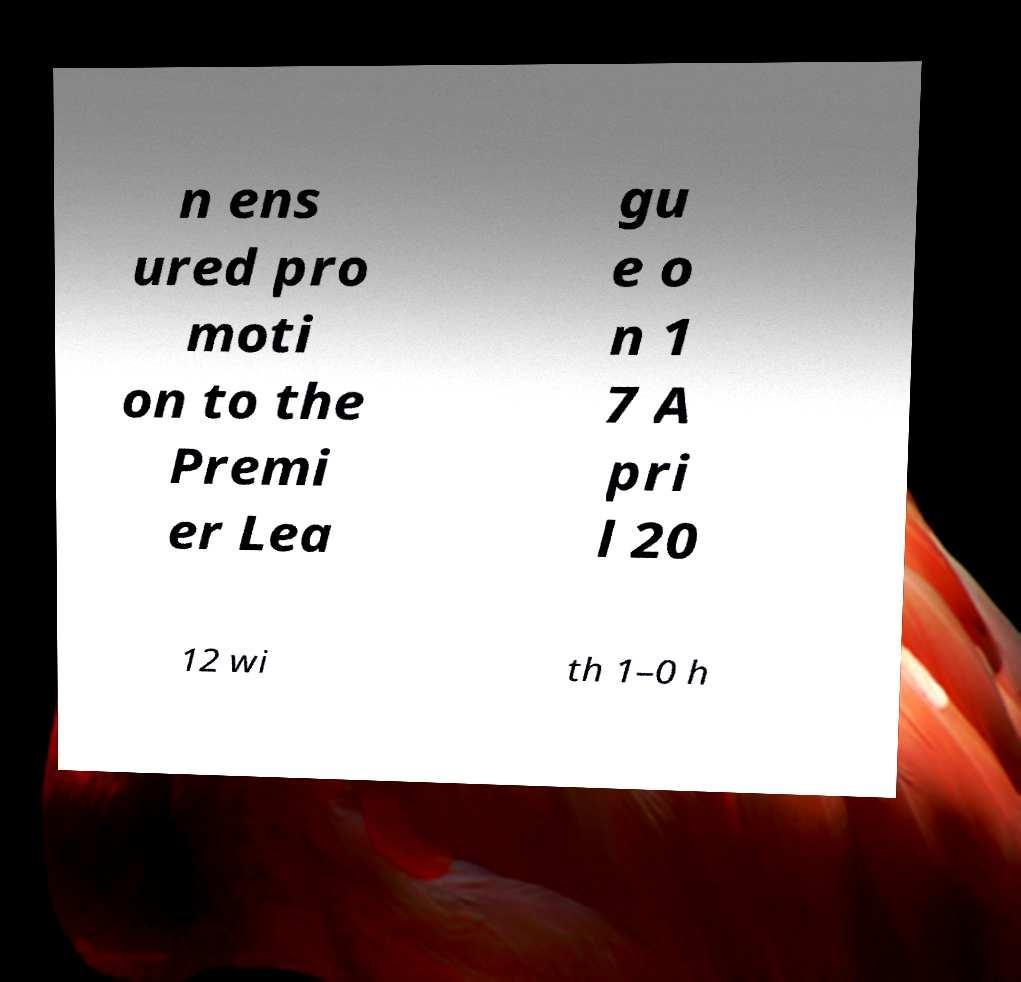I need the written content from this picture converted into text. Can you do that? n ens ured pro moti on to the Premi er Lea gu e o n 1 7 A pri l 20 12 wi th 1–0 h 